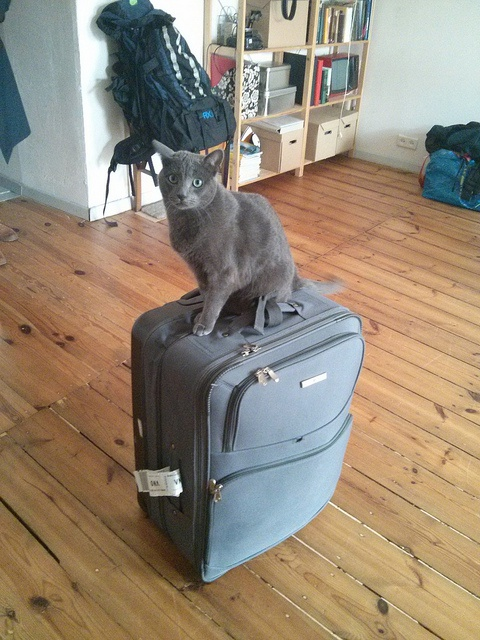Describe the objects in this image and their specific colors. I can see suitcase in darkblue, black, darkgray, gray, and lightblue tones, cat in darkblue, gray, darkgray, and black tones, backpack in darkblue, black, and blue tones, backpack in darkblue, blue, black, and teal tones, and book in darkblue, ivory, gray, darkgray, and tan tones in this image. 